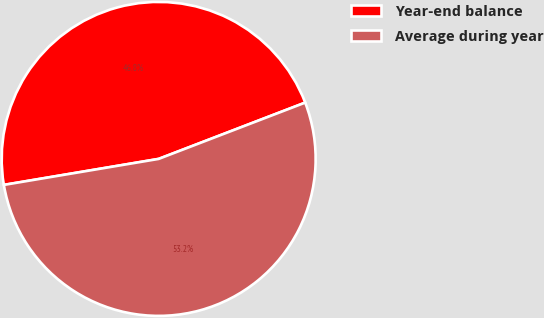Convert chart to OTSL. <chart><loc_0><loc_0><loc_500><loc_500><pie_chart><fcel>Year-end balance<fcel>Average during year<nl><fcel>46.81%<fcel>53.19%<nl></chart> 